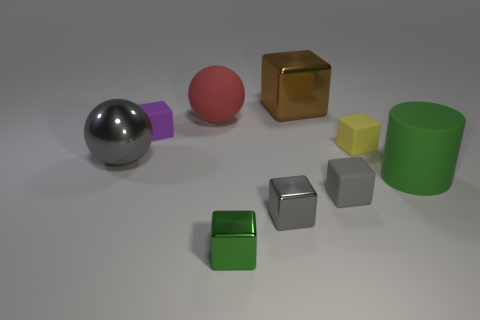Can you tell me about the colors and materials of these objects? Certainly, the scene features objects with matte and reflective surfaces. The colors include silver-gray, gold, green, yellow, red, and purple, with the cubes and the cylinder having distinctly solid and vivid tones. The metallic textures on the sphere and cube exude a shiny appearance, while the others have a diffused look, which might indicate different material properties. 